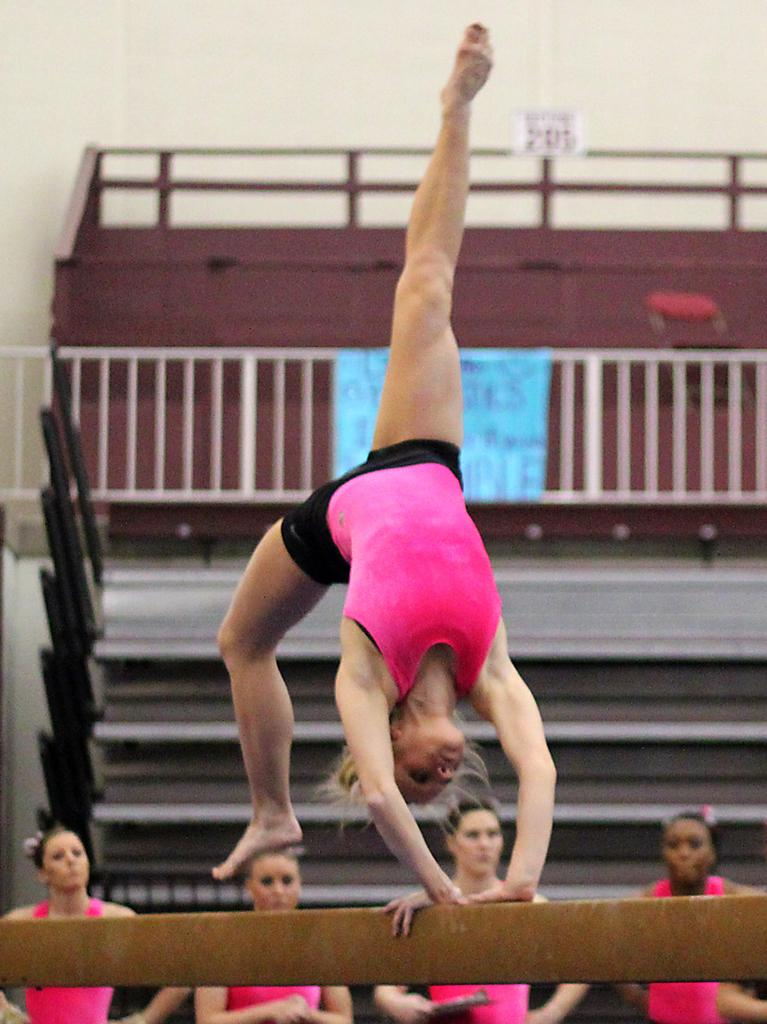Who is the main subject in the image? There is a woman in the image. What is the woman wearing? The woman is wearing a pink vest. What activity is the woman engaged in? The woman is doing gymnastics on a wooden block. Can you describe the background of the image? There are other women standing in the background, along with steps and a railing following the steps. What type of street is visible in the image? There is no street visible in the image; it features a woman doing gymnastics on a wooden block with other women and architectural elements in the background. 